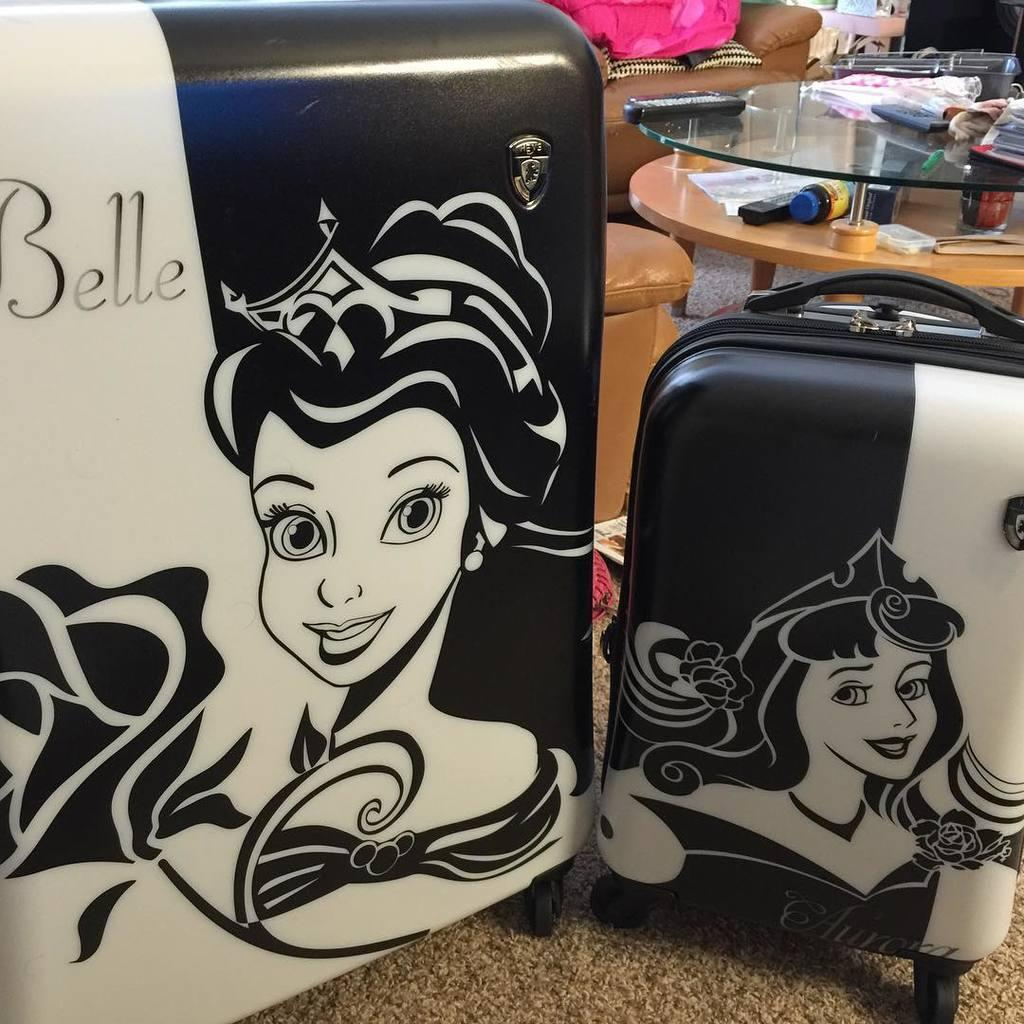What piece of furniture is located on the right side of the image? There is a table on the right side of the image. What items are on the table? There is a bottle and a paper on the table. What objects are on the left side of the image? There are two suitcases on the left side of the image. What can be seen in the background of the image? There is a sofa visible in the background of the image. What type of land can be seen through the window in the image? There is no window or land visible in the image. What type of milk is being poured from the bottle on the table? There is no milk present in the image; it is a bottle, but its contents are not specified. 